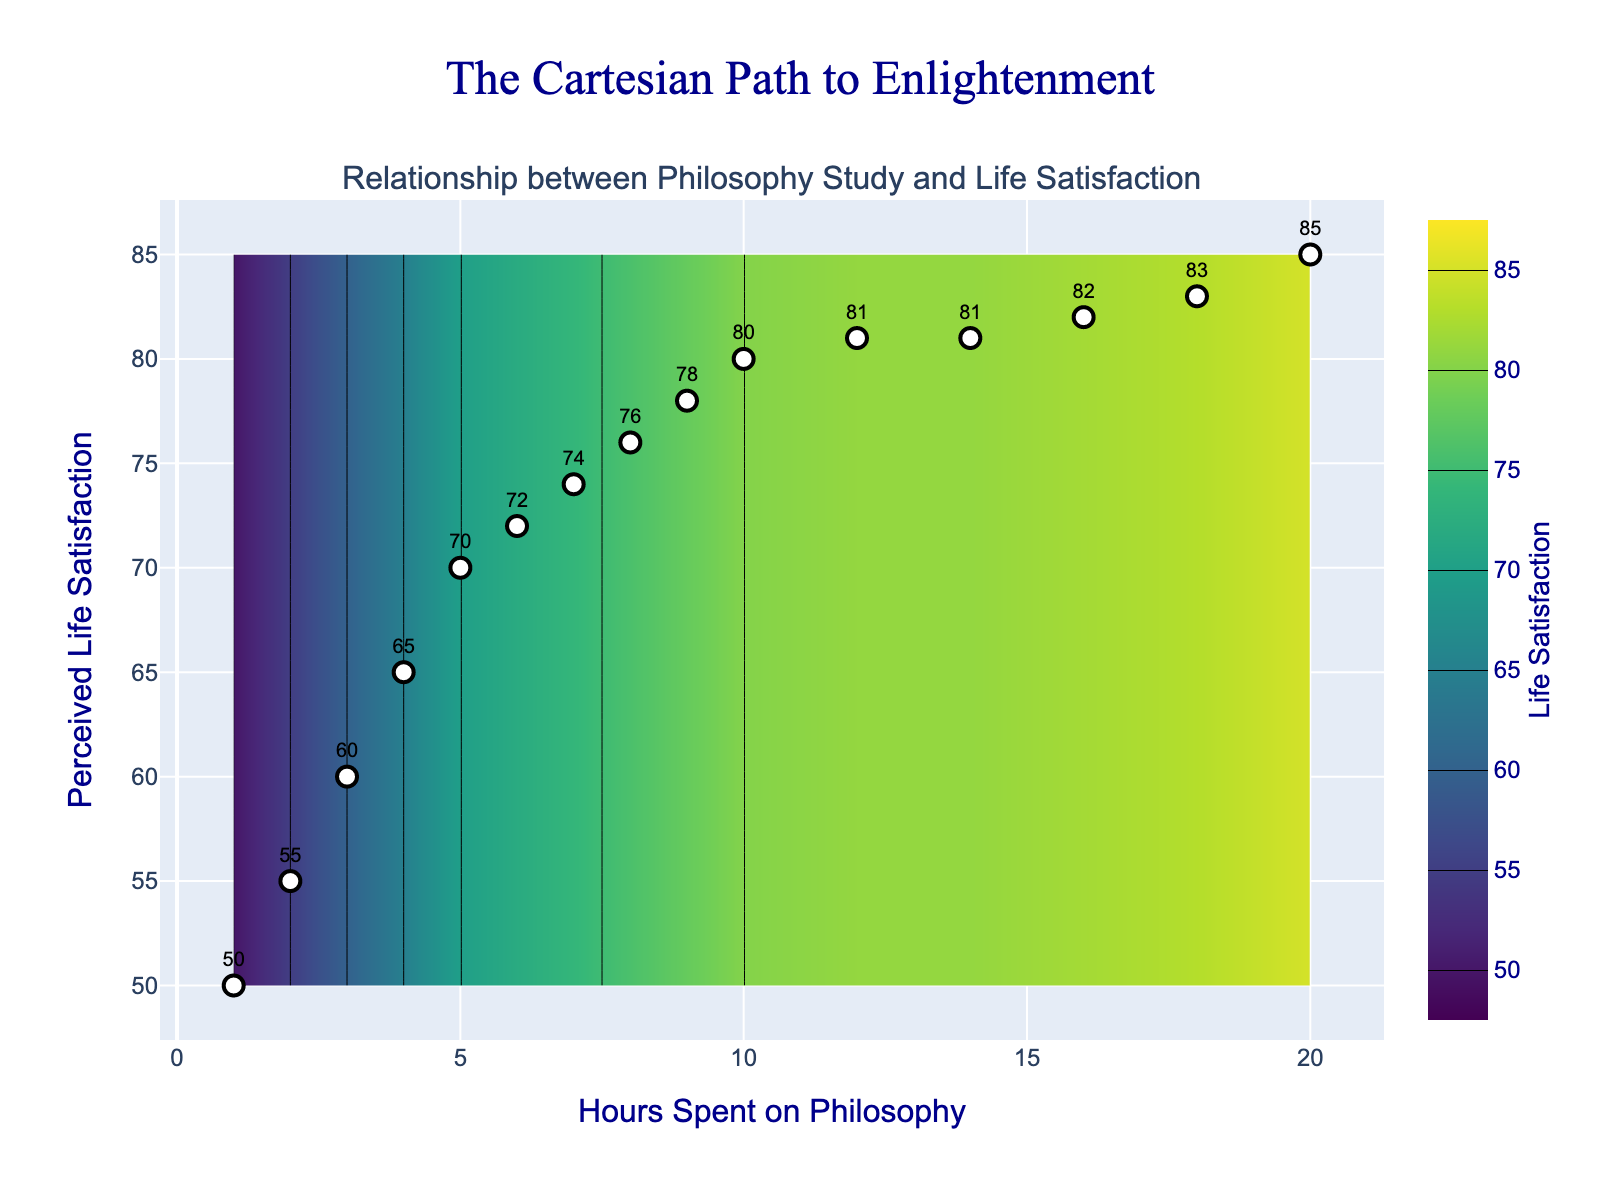What is the title of the plot? The title is clearly written at the top center of the figure.
Answer: The Cartesian Path to Enlightenment What is the relationship between hours spent on philosophy and perceived life satisfaction? The plot shows a positive trend; as hours spent on philosophy study increase, perceived life satisfaction tends to go up as well.
Answer: Positive trend How many data points are plotted as markers? Each data point corresponds to a unique combination of hours spent on philosophy and perceived life satisfaction. Counting the markers, we find there are 15 data points.
Answer: 15 What is the perceived life satisfaction when 10 hours are spent on philosophy study? Locate the marker on the x-axis at 10 hours and check the y-axis value. The text label on the marker indicates the perceived life satisfaction.
Answer: 80 Is there a noticeable plateau in life satisfaction as the hours of study increase? By observing the contour plot, we see that around 12-14 hours, the perceived life satisfaction values hover around 81, indicating a plateau.
Answer: Yes, at around 12-14 hours What life satisfaction level corresponds to the darkest color on the contour plot? The contour plot uses a Viridis color scale where darker areas represent higher values. Hence, the darkest color corresponds to the highest contour at 85.
Answer: 85 At what range of hours spent studying philosophy does the perceived life satisfaction level off? By examining the contour lines that are closer together and horizontal, the life satisfaction levels off between 12 to 20 hours.
Answer: Between 12 to 20 hours Compare the perceived life satisfaction for 4 hours and 16 hours of philosophy study. Which is higher? Check the specific markers and their labels; the marker at 4 hours shows a life satisfaction of 65, and at 16 hours, it’s 82.
Answer: 16 hours What range of hours shows an increase in perceived life satisfaction tiers in 5-unit increments on the contour lines? The contour lines are labeled at intervals of 5, starting from 50 up to 85. Analyze the intervals where the flat contours represent 5-unit increments. This change is noticeable from 1 to 20 hours.
Answer: 1 to 20 hours Is there any point at which increasing hours spent on philosophy does not increase perceived life satisfaction? Observing the contour plot, around 12-14 hours, the life satisfaction level (81) does not increase significantly until after 18 hours, showing a period where additional study hours have little effect.
Answer: Yes, between 12-14 hours 